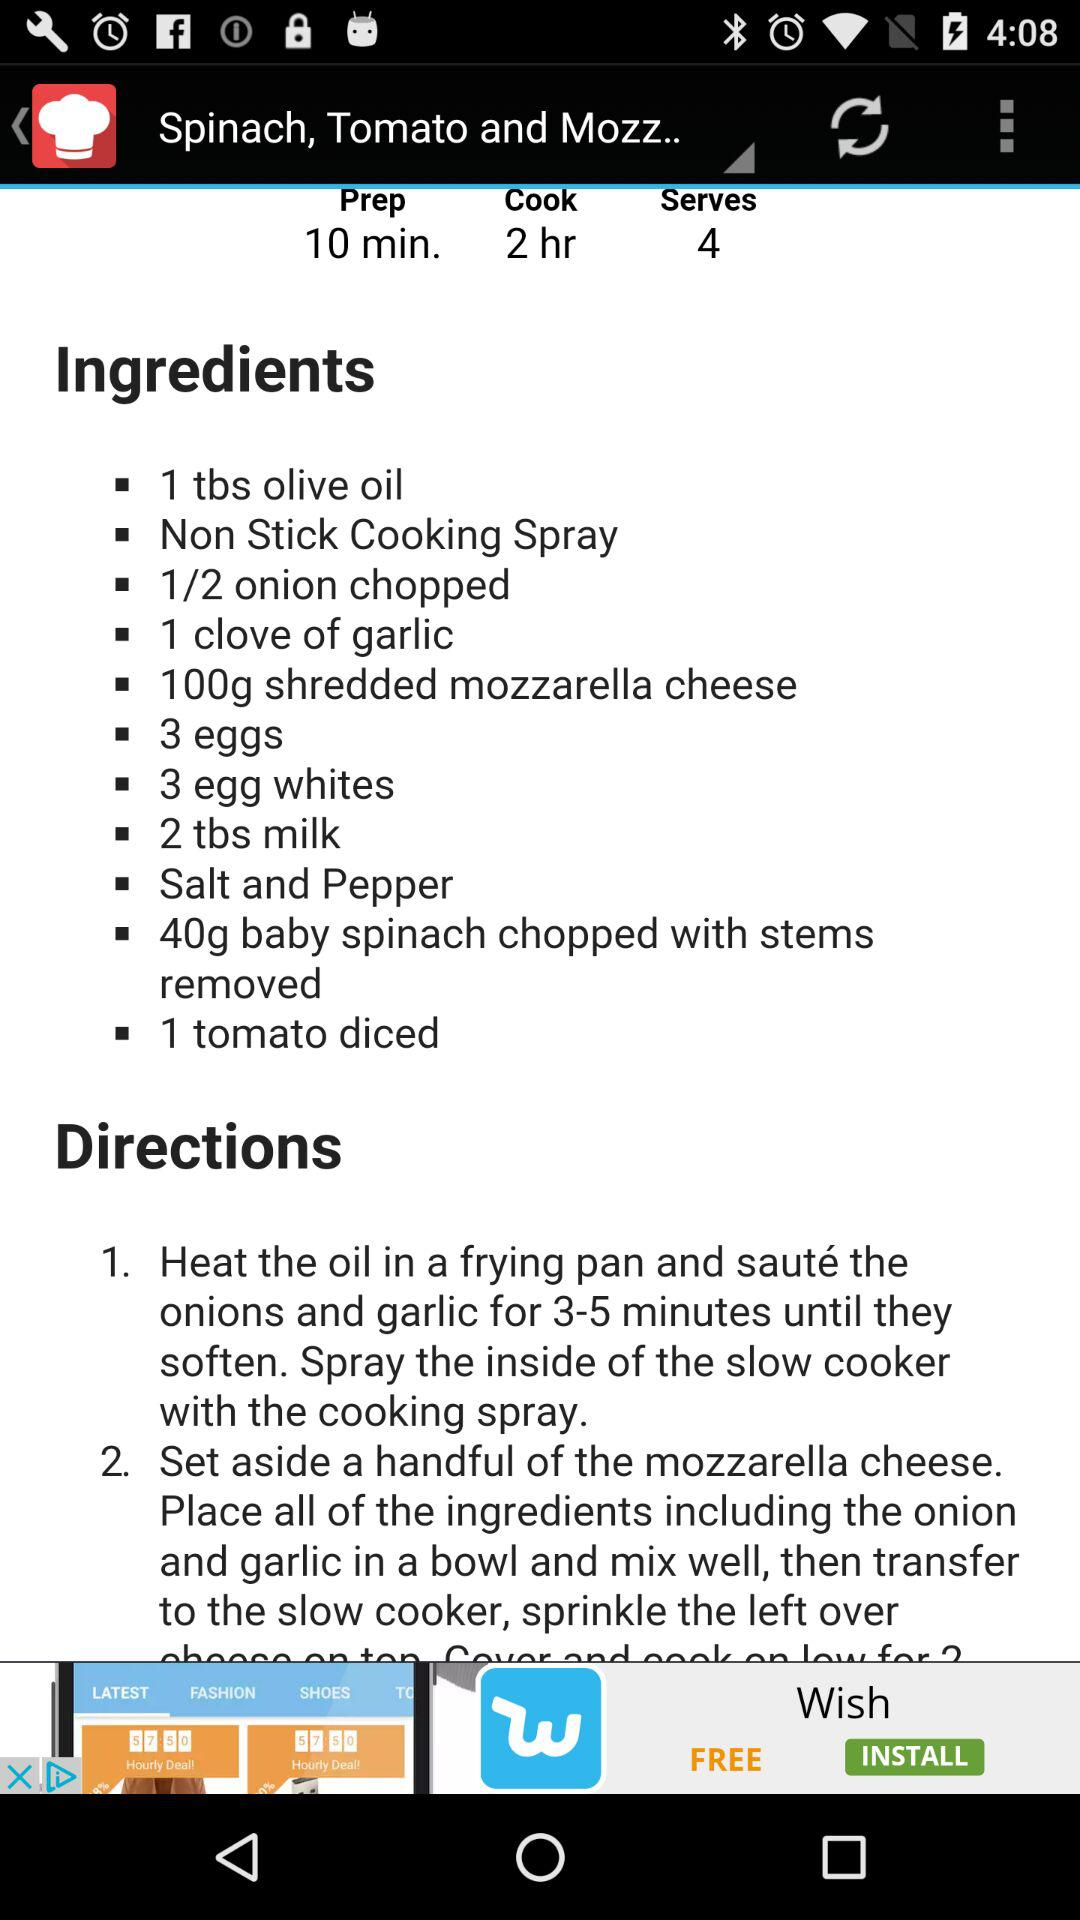How many eggs do we need to make the dish? You need 3 eggs to make the dish. 